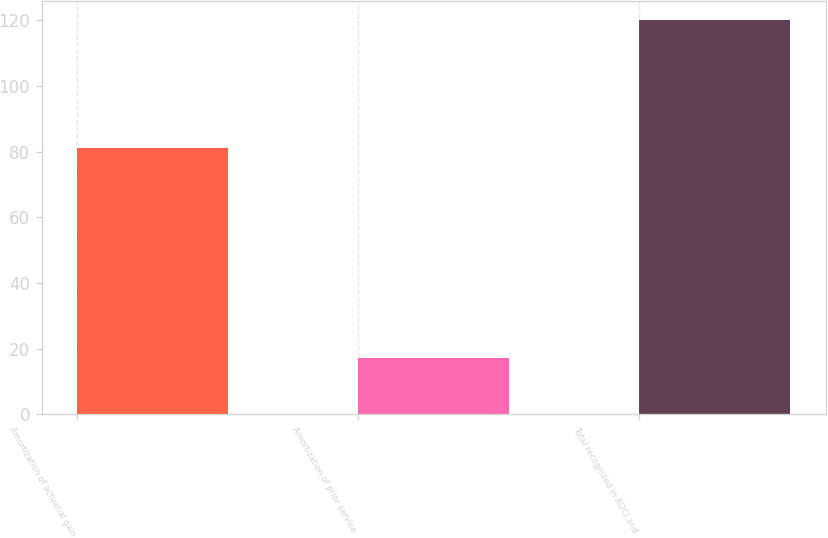Convert chart to OTSL. <chart><loc_0><loc_0><loc_500><loc_500><bar_chart><fcel>Amortization of actuarial gain<fcel>Amortization of prior service<fcel>Total recognized in AOCI and<nl><fcel>81<fcel>17<fcel>120<nl></chart> 